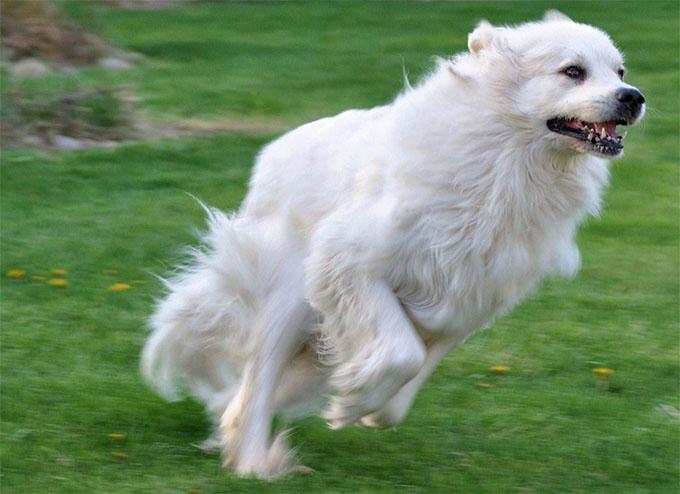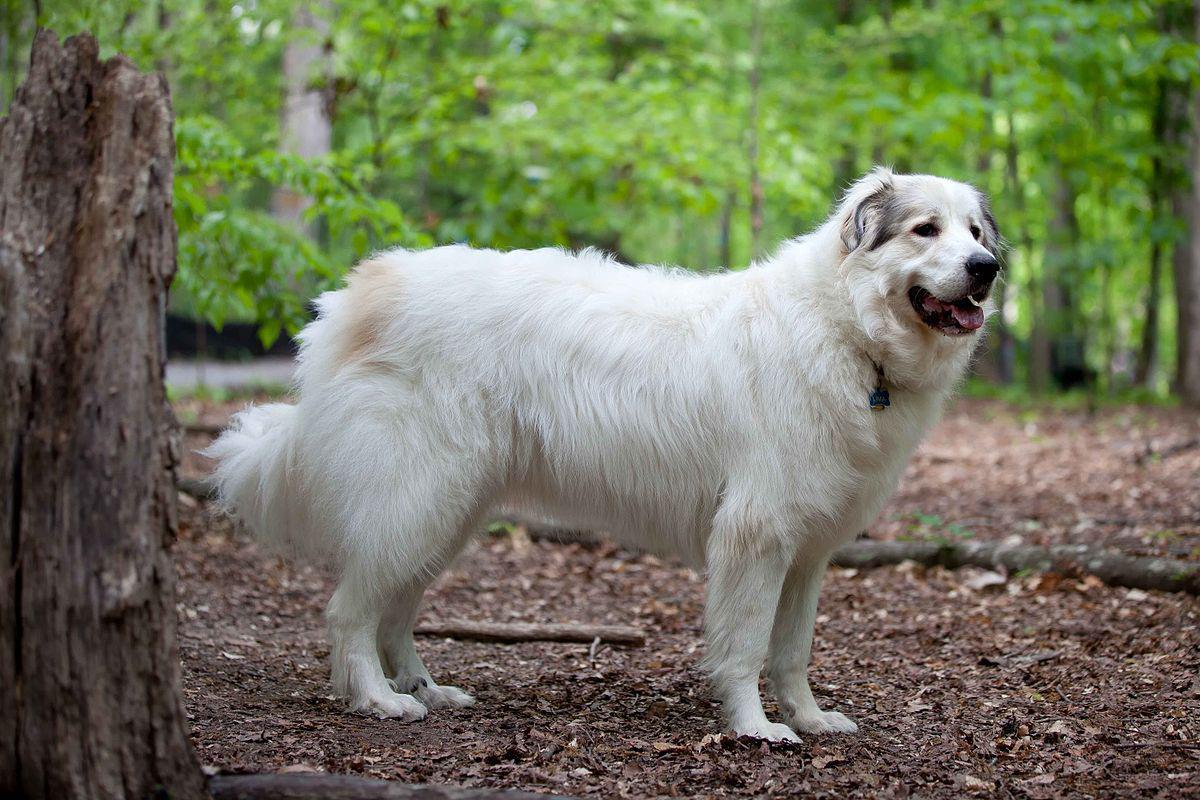The first image is the image on the left, the second image is the image on the right. Evaluate the accuracy of this statement regarding the images: "There are three dogs.". Is it true? Answer yes or no. No. The first image is the image on the left, the second image is the image on the right. Assess this claim about the two images: "There are more than two dogs". Correct or not? Answer yes or no. No. 